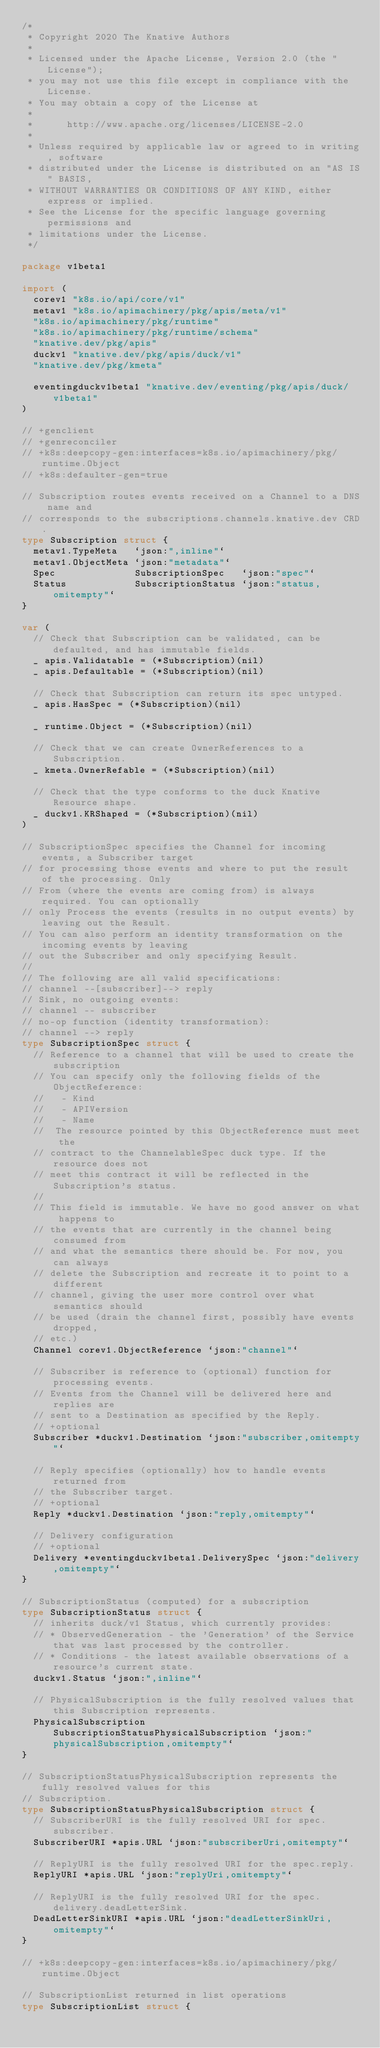Convert code to text. <code><loc_0><loc_0><loc_500><loc_500><_Go_>/*
 * Copyright 2020 The Knative Authors
 *
 * Licensed under the Apache License, Version 2.0 (the "License");
 * you may not use this file except in compliance with the License.
 * You may obtain a copy of the License at
 *
 *      http://www.apache.org/licenses/LICENSE-2.0
 *
 * Unless required by applicable law or agreed to in writing, software
 * distributed under the License is distributed on an "AS IS" BASIS,
 * WITHOUT WARRANTIES OR CONDITIONS OF ANY KIND, either express or implied.
 * See the License for the specific language governing permissions and
 * limitations under the License.
 */

package v1beta1

import (
	corev1 "k8s.io/api/core/v1"
	metav1 "k8s.io/apimachinery/pkg/apis/meta/v1"
	"k8s.io/apimachinery/pkg/runtime"
	"k8s.io/apimachinery/pkg/runtime/schema"
	"knative.dev/pkg/apis"
	duckv1 "knative.dev/pkg/apis/duck/v1"
	"knative.dev/pkg/kmeta"

	eventingduckv1beta1 "knative.dev/eventing/pkg/apis/duck/v1beta1"
)

// +genclient
// +genreconciler
// +k8s:deepcopy-gen:interfaces=k8s.io/apimachinery/pkg/runtime.Object
// +k8s:defaulter-gen=true

// Subscription routes events received on a Channel to a DNS name and
// corresponds to the subscriptions.channels.knative.dev CRD.
type Subscription struct {
	metav1.TypeMeta   `json:",inline"`
	metav1.ObjectMeta `json:"metadata"`
	Spec              SubscriptionSpec   `json:"spec"`
	Status            SubscriptionStatus `json:"status,omitempty"`
}

var (
	// Check that Subscription can be validated, can be defaulted, and has immutable fields.
	_ apis.Validatable = (*Subscription)(nil)
	_ apis.Defaultable = (*Subscription)(nil)

	// Check that Subscription can return its spec untyped.
	_ apis.HasSpec = (*Subscription)(nil)

	_ runtime.Object = (*Subscription)(nil)

	// Check that we can create OwnerReferences to a Subscription.
	_ kmeta.OwnerRefable = (*Subscription)(nil)

	// Check that the type conforms to the duck Knative Resource shape.
	_ duckv1.KRShaped = (*Subscription)(nil)
)

// SubscriptionSpec specifies the Channel for incoming events, a Subscriber target
// for processing those events and where to put the result of the processing. Only
// From (where the events are coming from) is always required. You can optionally
// only Process the events (results in no output events) by leaving out the Result.
// You can also perform an identity transformation on the incoming events by leaving
// out the Subscriber and only specifying Result.
//
// The following are all valid specifications:
// channel --[subscriber]--> reply
// Sink, no outgoing events:
// channel -- subscriber
// no-op function (identity transformation):
// channel --> reply
type SubscriptionSpec struct {
	// Reference to a channel that will be used to create the subscription
	// You can specify only the following fields of the ObjectReference:
	//   - Kind
	//   - APIVersion
	//   - Name
	//  The resource pointed by this ObjectReference must meet the
	// contract to the ChannelableSpec duck type. If the resource does not
	// meet this contract it will be reflected in the Subscription's status.
	//
	// This field is immutable. We have no good answer on what happens to
	// the events that are currently in the channel being consumed from
	// and what the semantics there should be. For now, you can always
	// delete the Subscription and recreate it to point to a different
	// channel, giving the user more control over what semantics should
	// be used (drain the channel first, possibly have events dropped,
	// etc.)
	Channel corev1.ObjectReference `json:"channel"`

	// Subscriber is reference to (optional) function for processing events.
	// Events from the Channel will be delivered here and replies are
	// sent to a Destination as specified by the Reply.
	// +optional
	Subscriber *duckv1.Destination `json:"subscriber,omitempty"`

	// Reply specifies (optionally) how to handle events returned from
	// the Subscriber target.
	// +optional
	Reply *duckv1.Destination `json:"reply,omitempty"`

	// Delivery configuration
	// +optional
	Delivery *eventingduckv1beta1.DeliverySpec `json:"delivery,omitempty"`
}

// SubscriptionStatus (computed) for a subscription
type SubscriptionStatus struct {
	// inherits duck/v1 Status, which currently provides:
	// * ObservedGeneration - the 'Generation' of the Service that was last processed by the controller.
	// * Conditions - the latest available observations of a resource's current state.
	duckv1.Status `json:",inline"`

	// PhysicalSubscription is the fully resolved values that this Subscription represents.
	PhysicalSubscription SubscriptionStatusPhysicalSubscription `json:"physicalSubscription,omitempty"`
}

// SubscriptionStatusPhysicalSubscription represents the fully resolved values for this
// Subscription.
type SubscriptionStatusPhysicalSubscription struct {
	// SubscriberURI is the fully resolved URI for spec.subscriber.
	SubscriberURI *apis.URL `json:"subscriberUri,omitempty"`

	// ReplyURI is the fully resolved URI for the spec.reply.
	ReplyURI *apis.URL `json:"replyUri,omitempty"`

	// ReplyURI is the fully resolved URI for the spec.delivery.deadLetterSink.
	DeadLetterSinkURI *apis.URL `json:"deadLetterSinkUri,omitempty"`
}

// +k8s:deepcopy-gen:interfaces=k8s.io/apimachinery/pkg/runtime.Object

// SubscriptionList returned in list operations
type SubscriptionList struct {</code> 